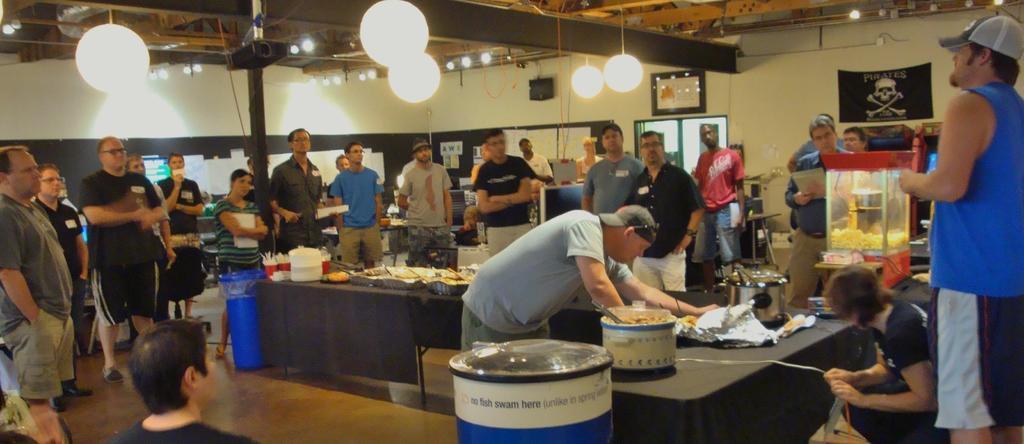Could you give a brief overview of what you see in this image? In this image there is a man who is standing near the table. On the table we can see bowl, food, spoon, foil paper, basket, water bottle and other objects. On the right there is a man who is standing near to the women. On the top we can see many lights. On the left we can see group of person standing near to the tables. Here we can see doors and posters. 